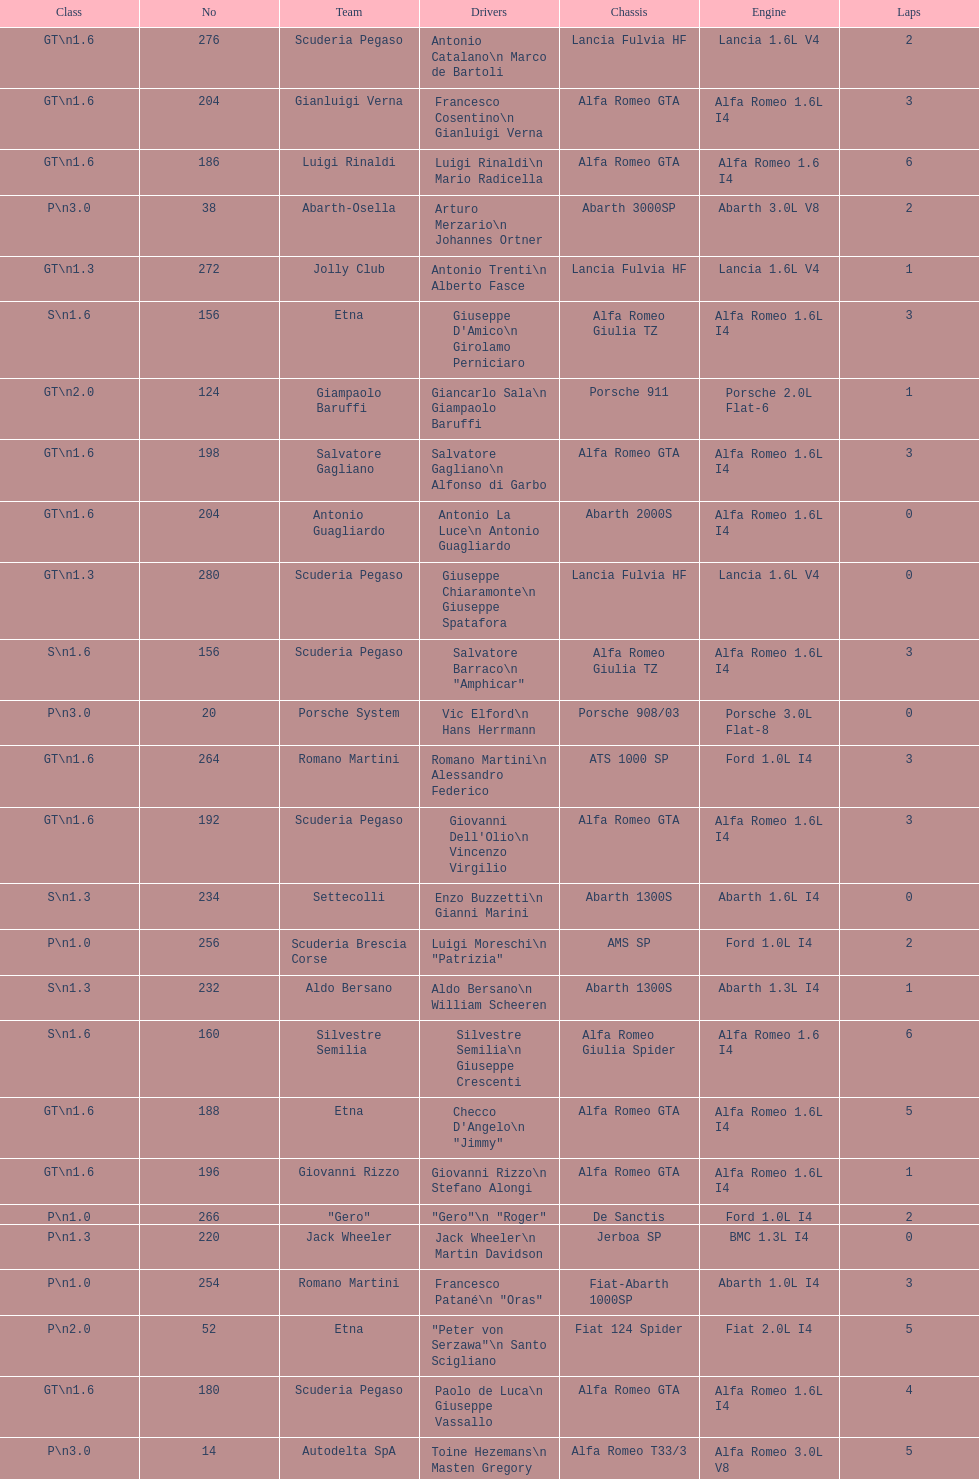How many laps does v10 kleber have? 5. 